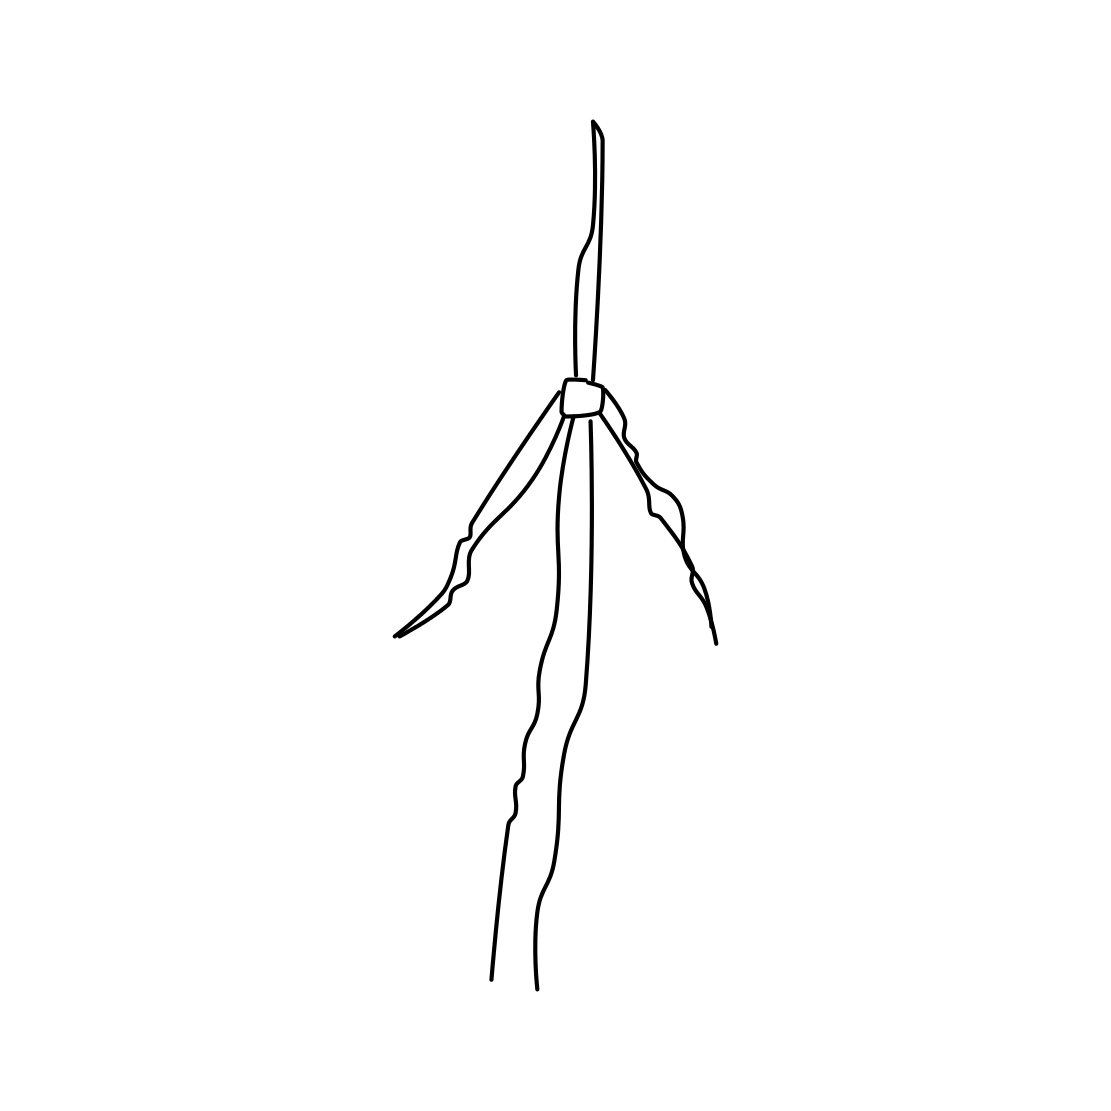Can you tell me what this image might look like if it were part of a natural landscape? If this image were placed within a natural landscape, it could be envisioned as a minimalist sculpture standing tall amidst rolling fields. Its sleek and basic form would contrast against the organic shapes of nature, possibly creating an interesting focal point that blends man-made artistry with natural beauty. 